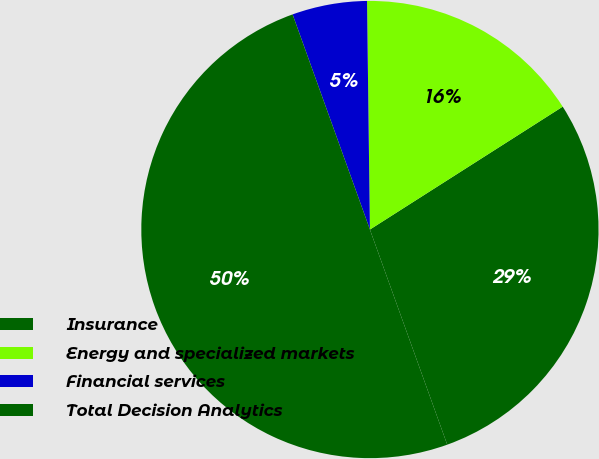Convert chart. <chart><loc_0><loc_0><loc_500><loc_500><pie_chart><fcel>Insurance<fcel>Energy and specialized markets<fcel>Financial services<fcel>Total Decision Analytics<nl><fcel>28.54%<fcel>16.17%<fcel>5.29%<fcel>50.0%<nl></chart> 